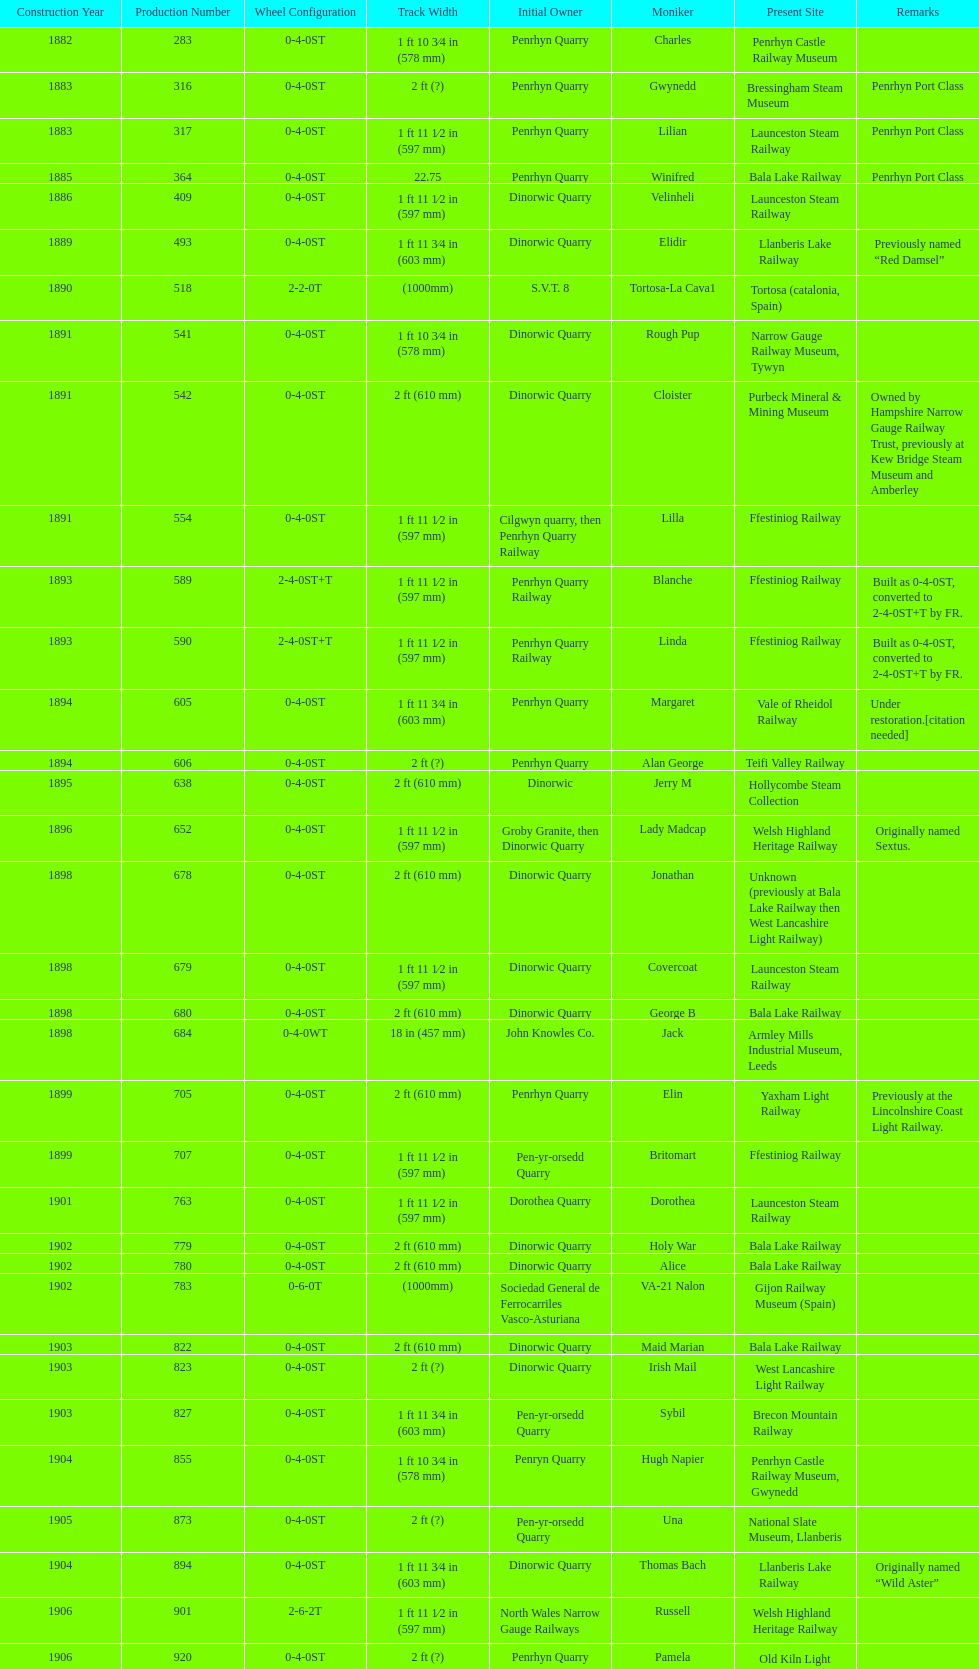Which works number had a larger gauge, 283 or 317? 317. 